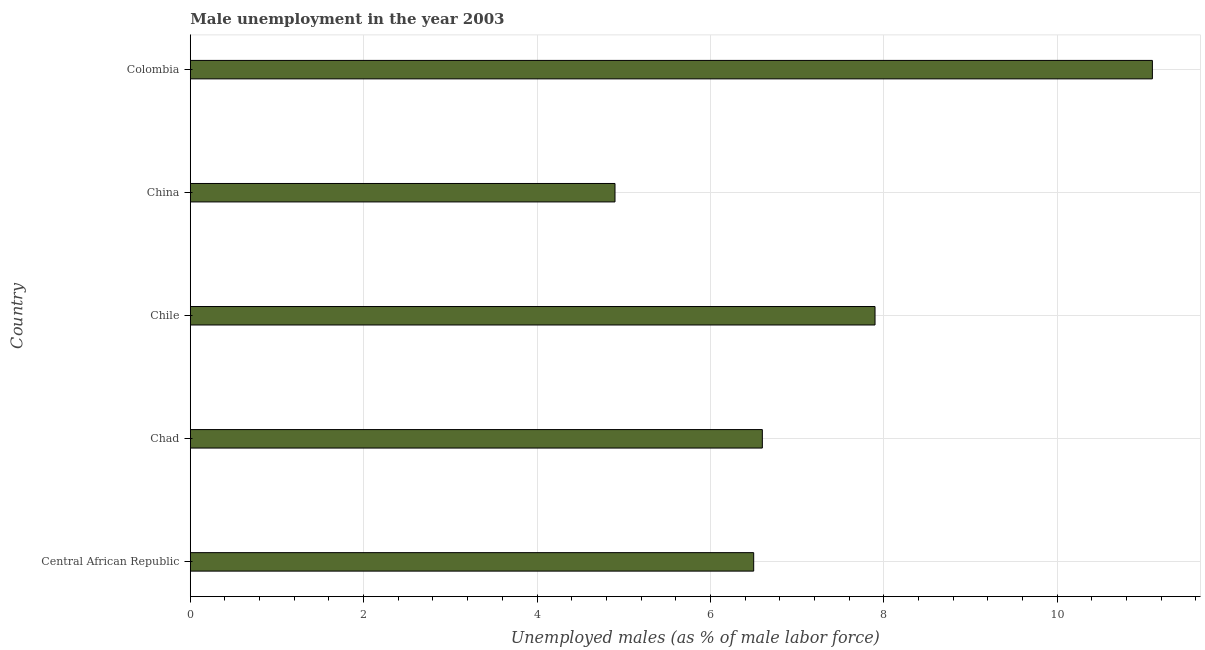Does the graph contain any zero values?
Give a very brief answer. No. Does the graph contain grids?
Give a very brief answer. Yes. What is the title of the graph?
Your answer should be very brief. Male unemployment in the year 2003. What is the label or title of the X-axis?
Offer a very short reply. Unemployed males (as % of male labor force). What is the unemployed males population in Chile?
Your response must be concise. 7.9. Across all countries, what is the maximum unemployed males population?
Give a very brief answer. 11.1. Across all countries, what is the minimum unemployed males population?
Your response must be concise. 4.9. In which country was the unemployed males population minimum?
Provide a succinct answer. China. What is the sum of the unemployed males population?
Offer a very short reply. 37. What is the average unemployed males population per country?
Your answer should be very brief. 7.4. What is the median unemployed males population?
Offer a very short reply. 6.6. What is the ratio of the unemployed males population in Chad to that in Chile?
Offer a very short reply. 0.83. What is the difference between the highest and the second highest unemployed males population?
Offer a terse response. 3.2. Is the sum of the unemployed males population in Central African Republic and China greater than the maximum unemployed males population across all countries?
Your answer should be very brief. Yes. In how many countries, is the unemployed males population greater than the average unemployed males population taken over all countries?
Your answer should be compact. 2. How many countries are there in the graph?
Your response must be concise. 5. What is the difference between two consecutive major ticks on the X-axis?
Provide a short and direct response. 2. Are the values on the major ticks of X-axis written in scientific E-notation?
Make the answer very short. No. What is the Unemployed males (as % of male labor force) in Chad?
Provide a short and direct response. 6.6. What is the Unemployed males (as % of male labor force) in Chile?
Make the answer very short. 7.9. What is the Unemployed males (as % of male labor force) of China?
Keep it short and to the point. 4.9. What is the Unemployed males (as % of male labor force) of Colombia?
Ensure brevity in your answer.  11.1. What is the difference between the Unemployed males (as % of male labor force) in Central African Republic and Chile?
Make the answer very short. -1.4. What is the difference between the Unemployed males (as % of male labor force) in Central African Republic and China?
Your answer should be compact. 1.6. What is the difference between the Unemployed males (as % of male labor force) in China and Colombia?
Your answer should be very brief. -6.2. What is the ratio of the Unemployed males (as % of male labor force) in Central African Republic to that in Chile?
Your answer should be compact. 0.82. What is the ratio of the Unemployed males (as % of male labor force) in Central African Republic to that in China?
Your response must be concise. 1.33. What is the ratio of the Unemployed males (as % of male labor force) in Central African Republic to that in Colombia?
Provide a short and direct response. 0.59. What is the ratio of the Unemployed males (as % of male labor force) in Chad to that in Chile?
Keep it short and to the point. 0.83. What is the ratio of the Unemployed males (as % of male labor force) in Chad to that in China?
Provide a short and direct response. 1.35. What is the ratio of the Unemployed males (as % of male labor force) in Chad to that in Colombia?
Ensure brevity in your answer.  0.59. What is the ratio of the Unemployed males (as % of male labor force) in Chile to that in China?
Offer a very short reply. 1.61. What is the ratio of the Unemployed males (as % of male labor force) in Chile to that in Colombia?
Your response must be concise. 0.71. What is the ratio of the Unemployed males (as % of male labor force) in China to that in Colombia?
Offer a very short reply. 0.44. 